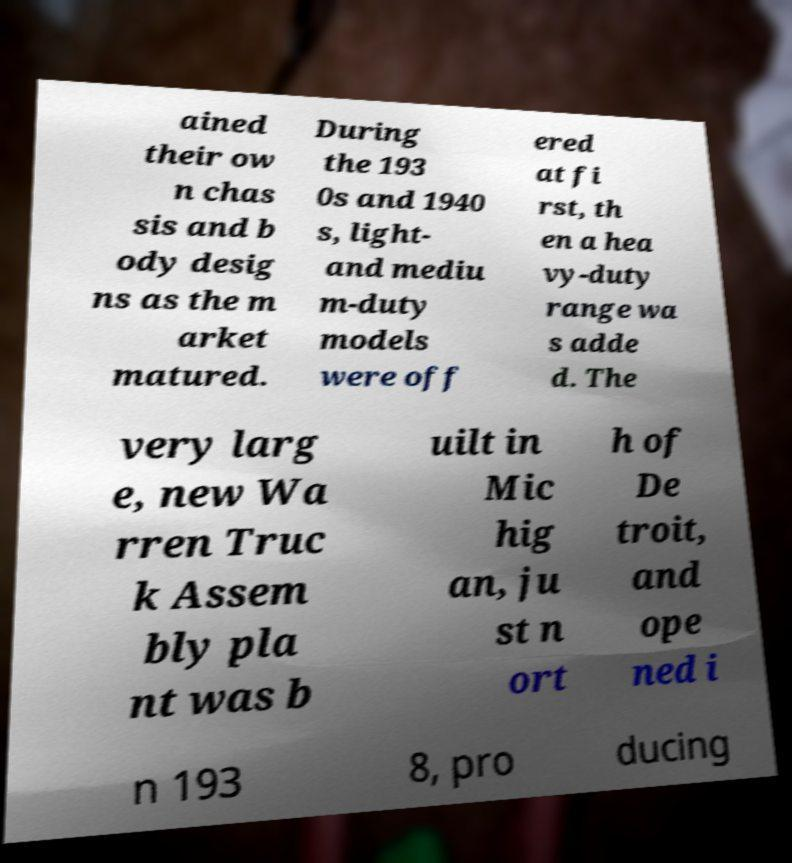For documentation purposes, I need the text within this image transcribed. Could you provide that? ained their ow n chas sis and b ody desig ns as the m arket matured. During the 193 0s and 1940 s, light- and mediu m-duty models were off ered at fi rst, th en a hea vy-duty range wa s adde d. The very larg e, new Wa rren Truc k Assem bly pla nt was b uilt in Mic hig an, ju st n ort h of De troit, and ope ned i n 193 8, pro ducing 